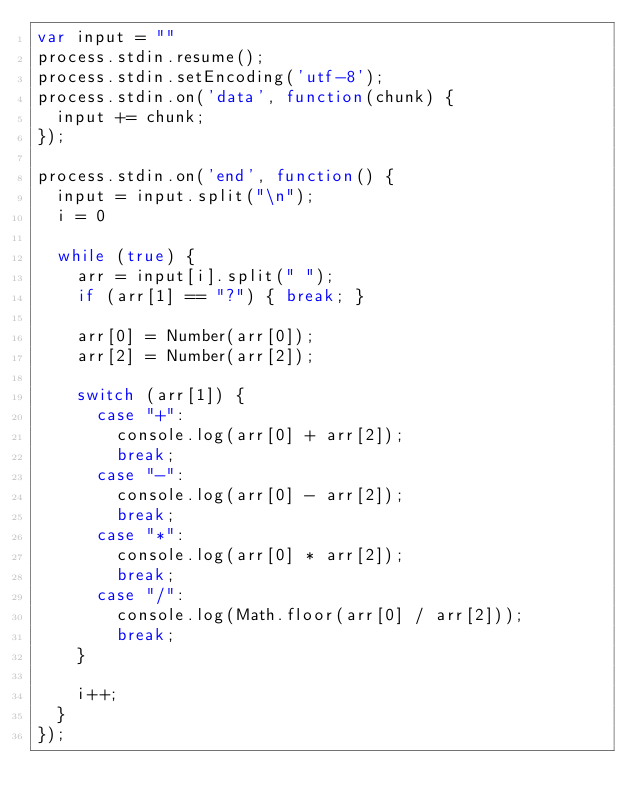<code> <loc_0><loc_0><loc_500><loc_500><_JavaScript_>var input = ""
process.stdin.resume();
process.stdin.setEncoding('utf-8');
process.stdin.on('data', function(chunk) {
  input += chunk;
});
  
process.stdin.on('end', function() {
  input = input.split("\n");
  i = 0
   
  while (true) {
    arr = input[i].split(" ");
    if (arr[1] == "?") { break; }
 
    arr[0] = Number(arr[0]);
    arr[2] = Number(arr[2]);
  
    switch (arr[1]) {
      case "+":
        console.log(arr[0] + arr[2]);
        break;
      case "-":
        console.log(arr[0] - arr[2]);
        break;
      case "*":
        console.log(arr[0] * arr[2]);
        break;
      case "/":
        console.log(Math.floor(arr[0] / arr[2]));
        break;
    }
  
    i++;
  }
});</code> 